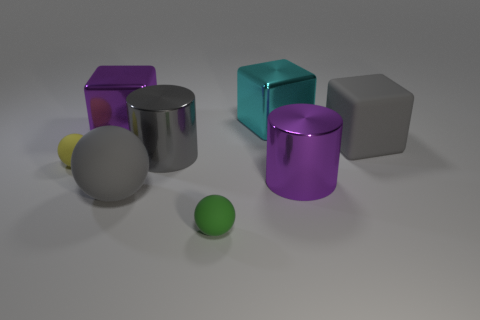Subtract all brown cubes. Subtract all brown cylinders. How many cubes are left? 3 Add 1 big green cylinders. How many objects exist? 9 Subtract all blocks. How many objects are left? 5 Add 1 big gray matte blocks. How many big gray matte blocks exist? 2 Subtract 0 purple balls. How many objects are left? 8 Subtract all gray cylinders. Subtract all small spheres. How many objects are left? 5 Add 1 large gray rubber objects. How many large gray rubber objects are left? 3 